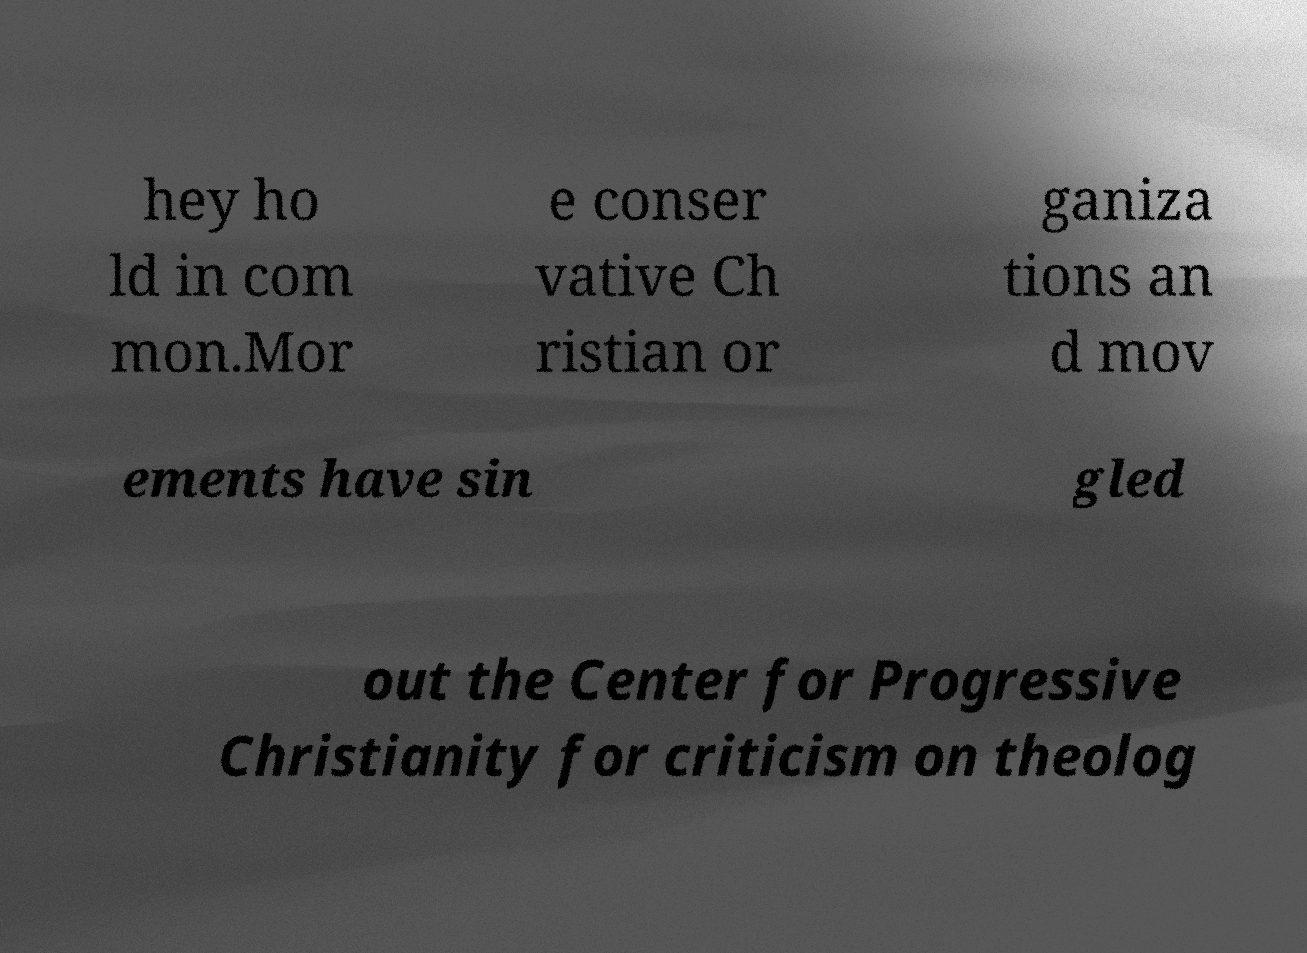What messages or text are displayed in this image? I need them in a readable, typed format. hey ho ld in com mon.Mor e conser vative Ch ristian or ganiza tions an d mov ements have sin gled out the Center for Progressive Christianity for criticism on theolog 